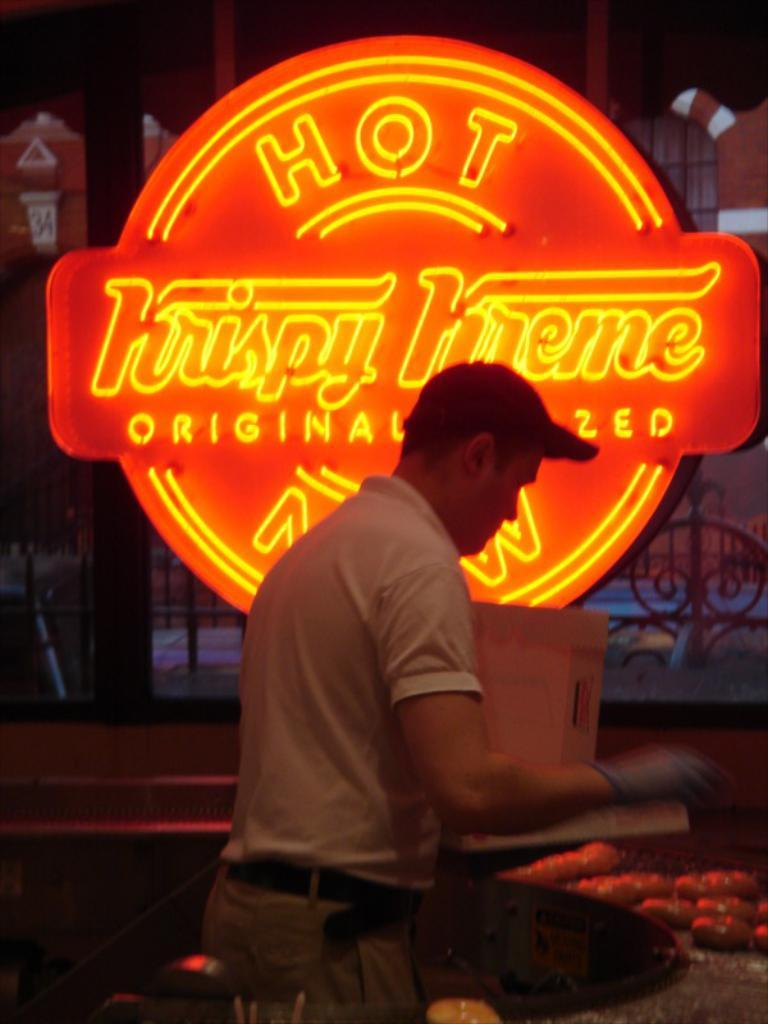What is the main subject of the image? The main subject of the image is a person standing in the middle of the image. What is located behind the person in the image? There is a banner behind the person. What is the purpose of the crib in the image? There is no crib present in the image. What type of tree is visible in the background of the image? There is no tree visible in the image; it only features a person standing in the middle and a banner behind them. 